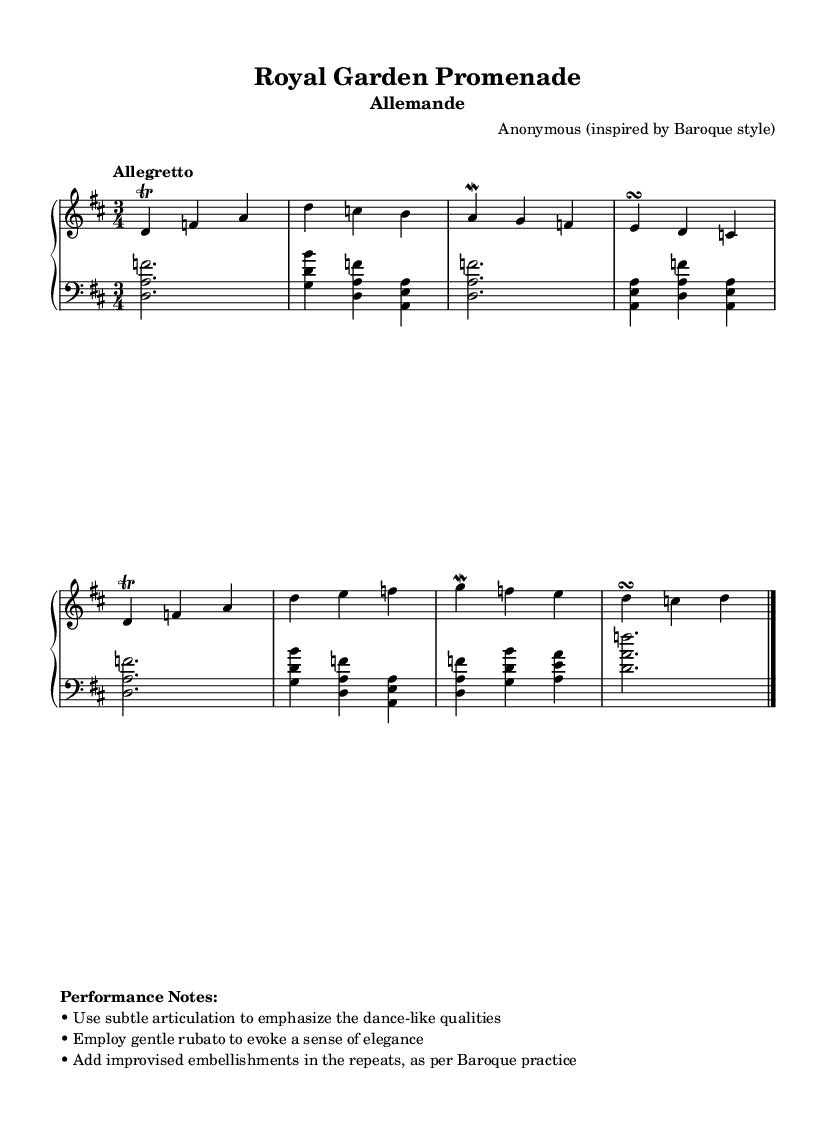What is the title of this piece? The title, as indicated in the header of the sheet music, is "Royal Garden Promenade."
Answer: Royal Garden Promenade What is the time signature of this piece? The time signature appears at the beginning of the music, which indicates there are three beats in a measure.
Answer: 3/4 What is the tempo marking for this piece? The tempo marking is specified in the score and states "Allegretto," suggesting a moderately fast pace.
Answer: Allegretto What key is this piece composed in? The key signature shown in the sheet music indicates it is in D major, which has two sharps (F# and C#).
Answer: D major What type of ornamentation is suggested for the repeats? The performance notes recommend adding improvised embellishments during the repeats, which is a common practice in Baroque music.
Answer: Embellishments Which section of the Baroque dance suite does this piece represent? The "Allemande" is a traditional dance form within Baroque suites, typically characterized by its moderate tempo.
Answer: Allemande What is the role of the left hand in this piece? The left hand primarily provides harmonic support with broken chords and occasional hand positioning for fuller sound, enhancing the overall texture.
Answer: Harmonic support 